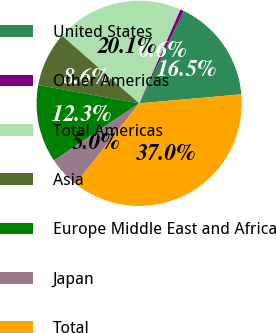Convert chart to OTSL. <chart><loc_0><loc_0><loc_500><loc_500><pie_chart><fcel>United States<fcel>Other Americas<fcel>Total Americas<fcel>Asia<fcel>Europe Middle East and Africa<fcel>Japan<fcel>Total<nl><fcel>16.45%<fcel>0.58%<fcel>20.1%<fcel>8.61%<fcel>12.26%<fcel>4.97%<fcel>37.03%<nl></chart> 